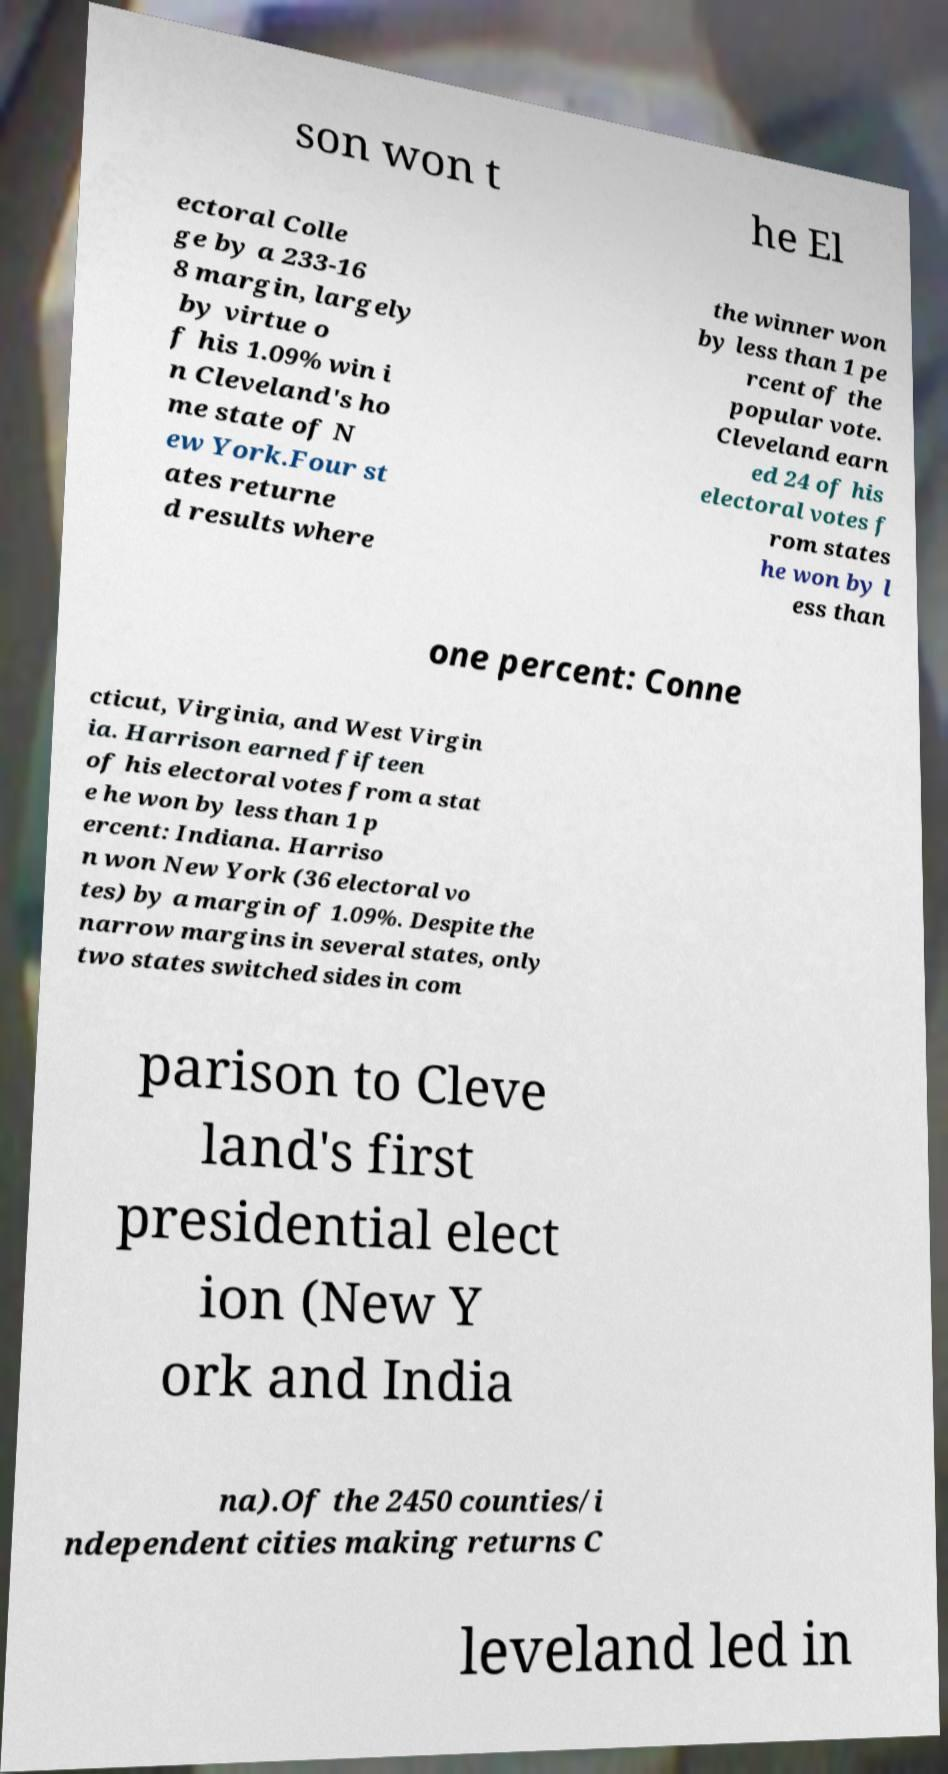Can you read and provide the text displayed in the image?This photo seems to have some interesting text. Can you extract and type it out for me? son won t he El ectoral Colle ge by a 233-16 8 margin, largely by virtue o f his 1.09% win i n Cleveland's ho me state of N ew York.Four st ates returne d results where the winner won by less than 1 pe rcent of the popular vote. Cleveland earn ed 24 of his electoral votes f rom states he won by l ess than one percent: Conne cticut, Virginia, and West Virgin ia. Harrison earned fifteen of his electoral votes from a stat e he won by less than 1 p ercent: Indiana. Harriso n won New York (36 electoral vo tes) by a margin of 1.09%. Despite the narrow margins in several states, only two states switched sides in com parison to Cleve land's first presidential elect ion (New Y ork and India na).Of the 2450 counties/i ndependent cities making returns C leveland led in 